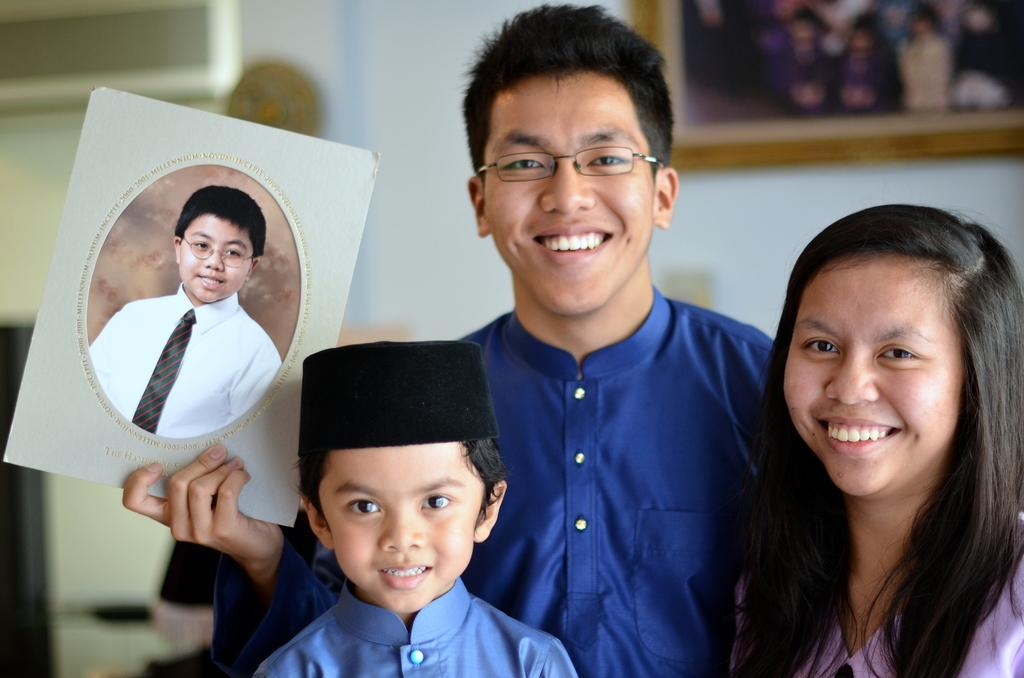Who are the people in the image? There is a couple and a boy in the image. What is the mood of the individuals in the image? All three individuals are smiling, which suggests a positive mood. What is the man holding in the image? The man is holding a photo frame in his hand. Can you describe the background of the image? There is a photo frame on the wall in the background of the image. What type of engine can be seen in the image? There is no engine present in the image. How many potatoes are visible in the image? There are no potatoes visible in the image. 